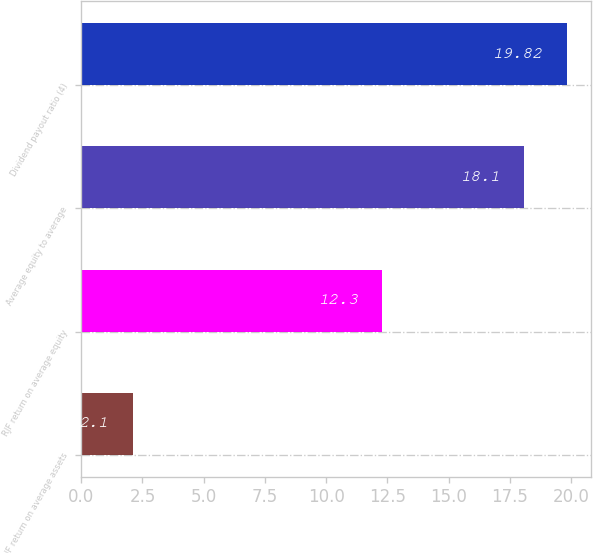Convert chart to OTSL. <chart><loc_0><loc_0><loc_500><loc_500><bar_chart><fcel>RJF return on average assets<fcel>RJF return on average equity<fcel>Average equity to average<fcel>Dividend payout ratio (4)<nl><fcel>2.1<fcel>12.3<fcel>18.1<fcel>19.82<nl></chart> 